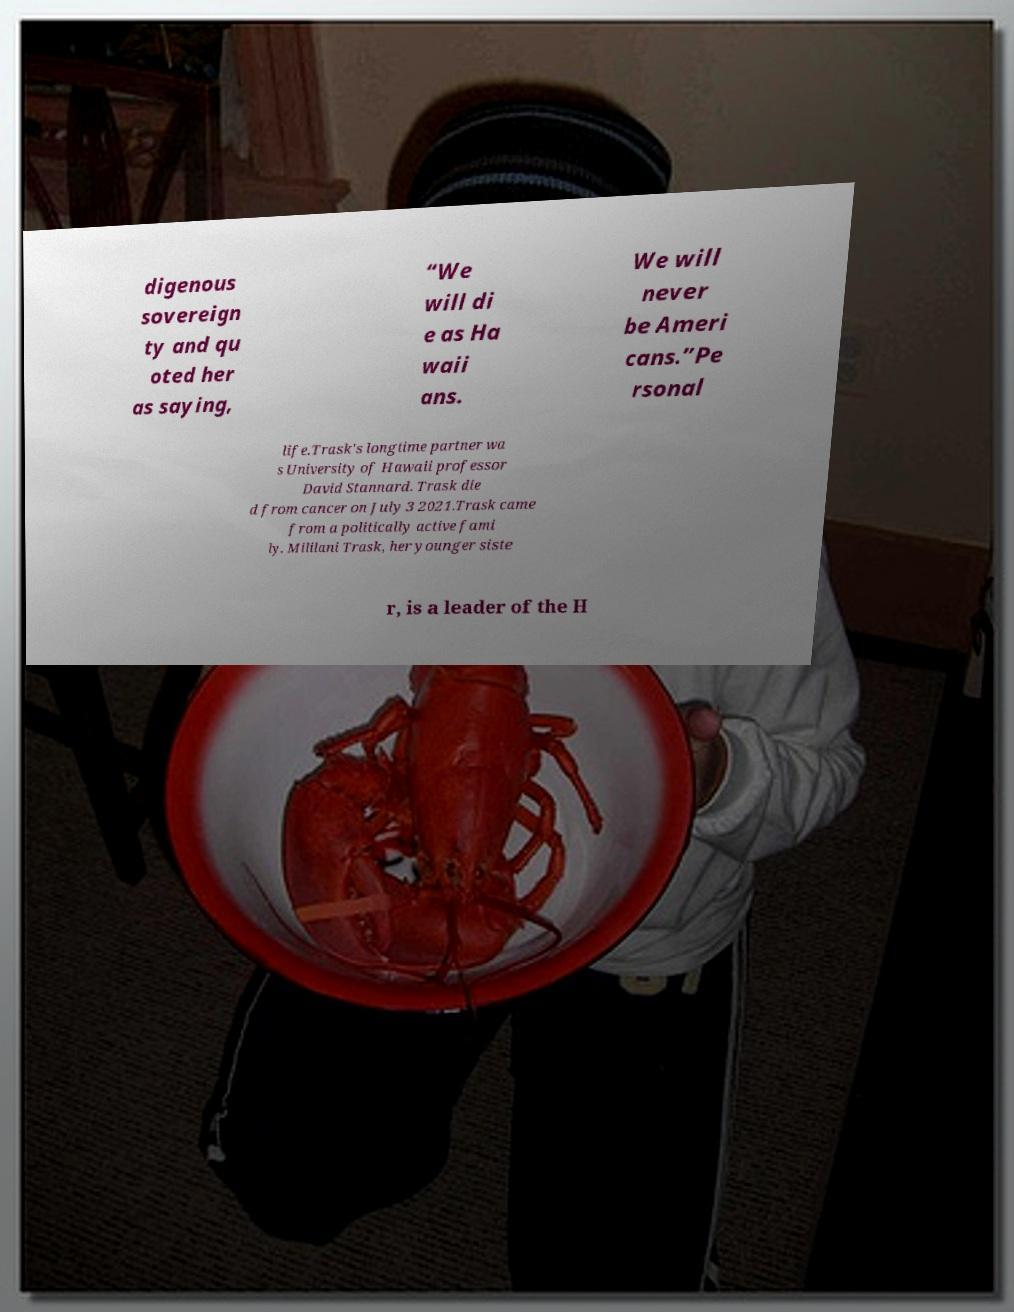Can you read and provide the text displayed in the image?This photo seems to have some interesting text. Can you extract and type it out for me? digenous sovereign ty and qu oted her as saying, “We will di e as Ha waii ans. We will never be Ameri cans.”Pe rsonal life.Trask's longtime partner wa s University of Hawaii professor David Stannard. Trask die d from cancer on July 3 2021.Trask came from a politically active fami ly. Mililani Trask, her younger siste r, is a leader of the H 